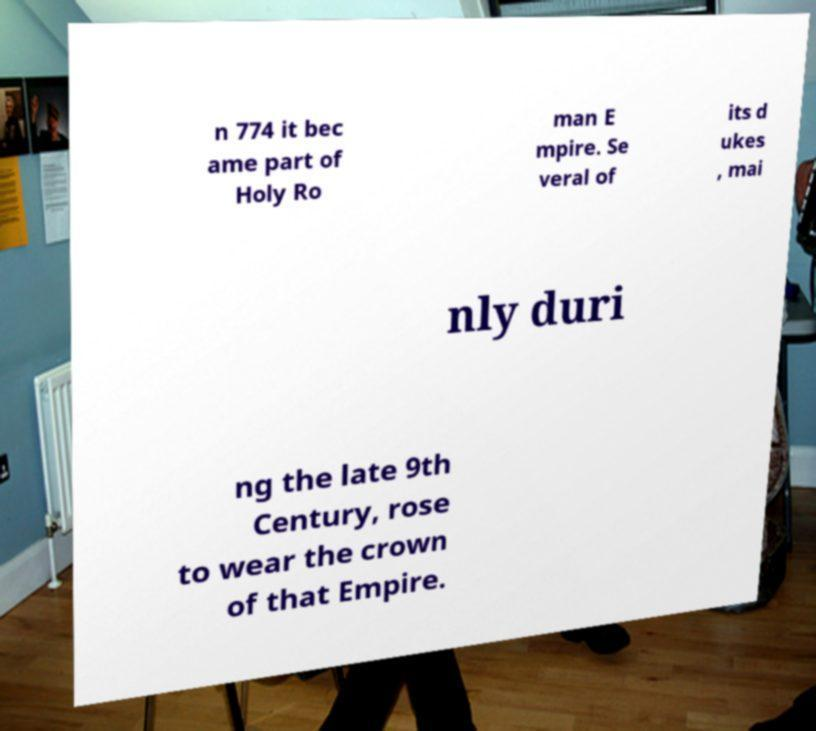For documentation purposes, I need the text within this image transcribed. Could you provide that? n 774 it bec ame part of Holy Ro man E mpire. Se veral of its d ukes , mai nly duri ng the late 9th Century, rose to wear the crown of that Empire. 